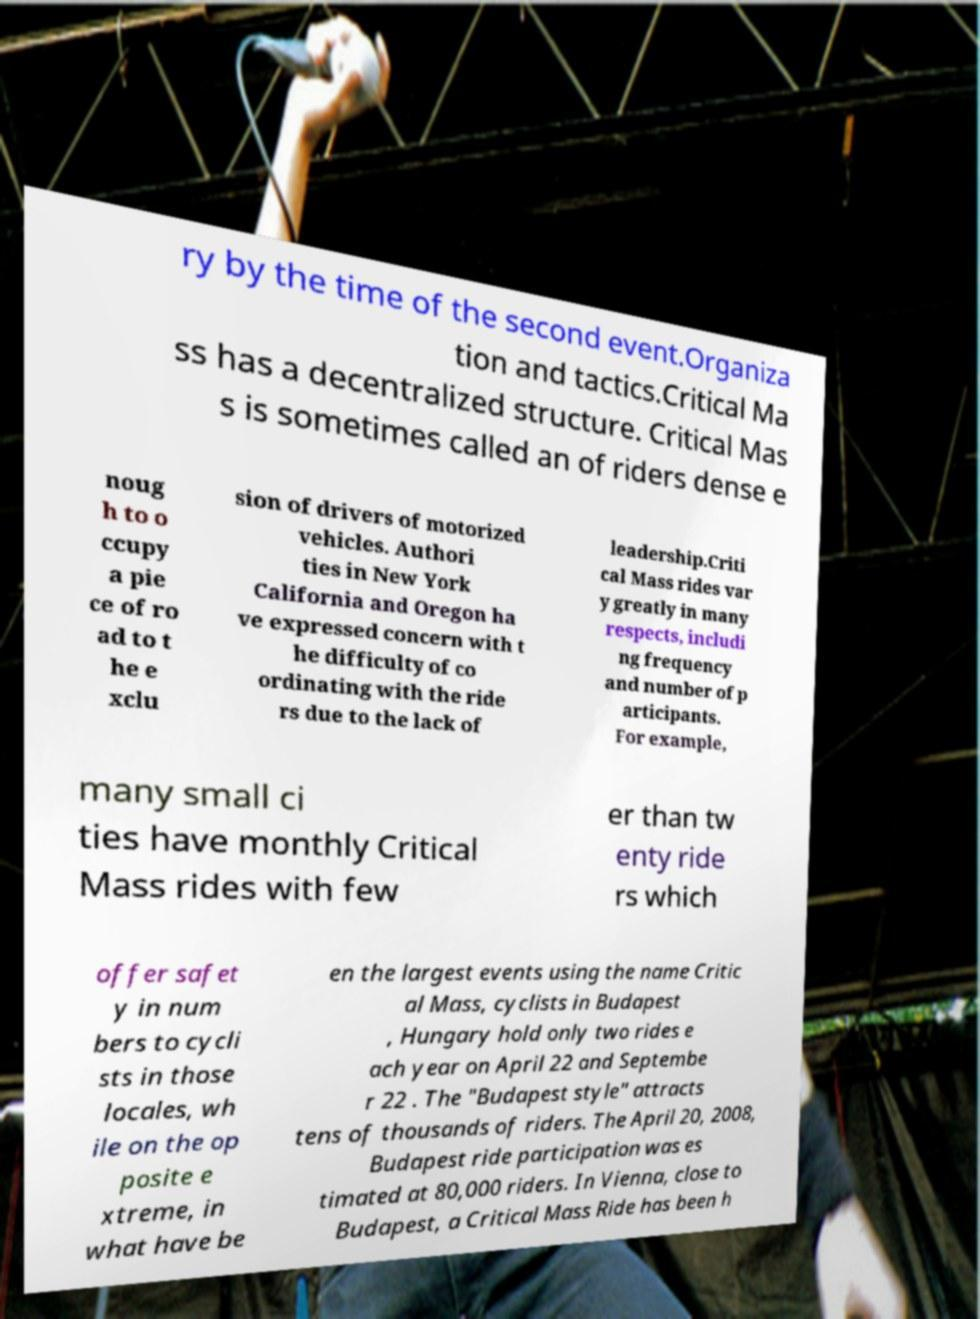Please read and relay the text visible in this image. What does it say? ry by the time of the second event.Organiza tion and tactics.Critical Ma ss has a decentralized structure. Critical Mas s is sometimes called an of riders dense e noug h to o ccupy a pie ce of ro ad to t he e xclu sion of drivers of motorized vehicles. Authori ties in New York California and Oregon ha ve expressed concern with t he difficulty of co ordinating with the ride rs due to the lack of leadership.Criti cal Mass rides var y greatly in many respects, includi ng frequency and number of p articipants. For example, many small ci ties have monthly Critical Mass rides with few er than tw enty ride rs which offer safet y in num bers to cycli sts in those locales, wh ile on the op posite e xtreme, in what have be en the largest events using the name Critic al Mass, cyclists in Budapest , Hungary hold only two rides e ach year on April 22 and Septembe r 22 . The "Budapest style" attracts tens of thousands of riders. The April 20, 2008, Budapest ride participation was es timated at 80,000 riders. In Vienna, close to Budapest, a Critical Mass Ride has been h 